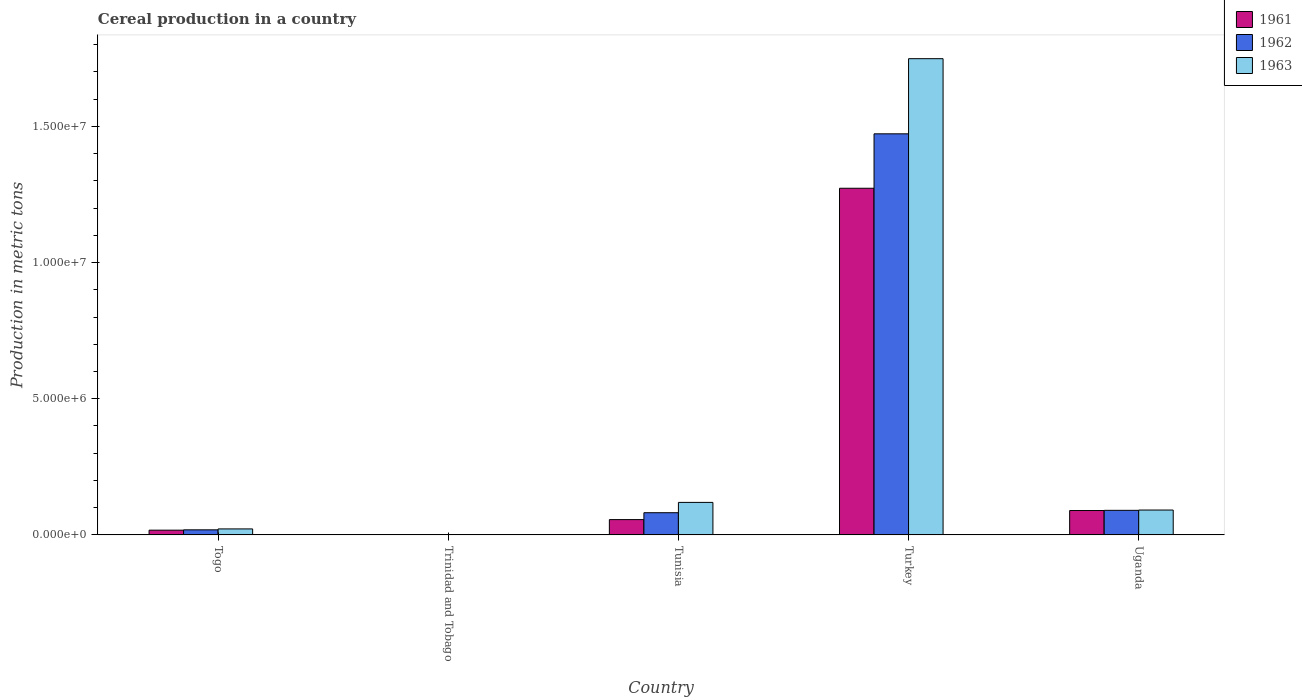How many groups of bars are there?
Keep it short and to the point. 5. Are the number of bars per tick equal to the number of legend labels?
Your response must be concise. Yes. How many bars are there on the 5th tick from the left?
Keep it short and to the point. 3. What is the label of the 5th group of bars from the left?
Provide a short and direct response. Uganda. What is the total cereal production in 1961 in Tunisia?
Make the answer very short. 5.62e+05. Across all countries, what is the maximum total cereal production in 1962?
Your answer should be compact. 1.47e+07. Across all countries, what is the minimum total cereal production in 1963?
Keep it short and to the point. 1.32e+04. In which country was the total cereal production in 1961 maximum?
Make the answer very short. Turkey. In which country was the total cereal production in 1962 minimum?
Your answer should be compact. Trinidad and Tobago. What is the total total cereal production in 1961 in the graph?
Offer a terse response. 1.44e+07. What is the difference between the total cereal production in 1961 in Togo and that in Trinidad and Tobago?
Your answer should be very brief. 1.61e+05. What is the difference between the total cereal production in 1962 in Togo and the total cereal production in 1961 in Trinidad and Tobago?
Provide a short and direct response. 1.73e+05. What is the average total cereal production in 1963 per country?
Provide a succinct answer. 3.97e+06. What is the difference between the total cereal production of/in 1962 and total cereal production of/in 1963 in Trinidad and Tobago?
Keep it short and to the point. 100. What is the ratio of the total cereal production in 1961 in Togo to that in Uganda?
Give a very brief answer. 0.19. Is the total cereal production in 1961 in Trinidad and Tobago less than that in Uganda?
Your answer should be compact. Yes. Is the difference between the total cereal production in 1962 in Togo and Uganda greater than the difference between the total cereal production in 1963 in Togo and Uganda?
Give a very brief answer. No. What is the difference between the highest and the second highest total cereal production in 1963?
Provide a short and direct response. -1.66e+07. What is the difference between the highest and the lowest total cereal production in 1962?
Your answer should be very brief. 1.47e+07. Is the sum of the total cereal production in 1961 in Togo and Tunisia greater than the maximum total cereal production in 1962 across all countries?
Provide a short and direct response. No. What does the 3rd bar from the right in Trinidad and Tobago represents?
Offer a terse response. 1961. How many bars are there?
Your answer should be very brief. 15. What is the difference between two consecutive major ticks on the Y-axis?
Offer a very short reply. 5.00e+06. Does the graph contain any zero values?
Offer a terse response. No. Where does the legend appear in the graph?
Give a very brief answer. Top right. What is the title of the graph?
Give a very brief answer. Cereal production in a country. Does "2004" appear as one of the legend labels in the graph?
Keep it short and to the point. No. What is the label or title of the Y-axis?
Your answer should be very brief. Production in metric tons. What is the Production in metric tons of 1961 in Togo?
Offer a terse response. 1.74e+05. What is the Production in metric tons in 1962 in Togo?
Your response must be concise. 1.86e+05. What is the Production in metric tons of 1963 in Togo?
Offer a very short reply. 2.20e+05. What is the Production in metric tons of 1961 in Trinidad and Tobago?
Your answer should be compact. 1.26e+04. What is the Production in metric tons of 1962 in Trinidad and Tobago?
Ensure brevity in your answer.  1.33e+04. What is the Production in metric tons in 1963 in Trinidad and Tobago?
Offer a terse response. 1.32e+04. What is the Production in metric tons of 1961 in Tunisia?
Provide a succinct answer. 5.62e+05. What is the Production in metric tons of 1962 in Tunisia?
Offer a terse response. 8.14e+05. What is the Production in metric tons of 1963 in Tunisia?
Make the answer very short. 1.19e+06. What is the Production in metric tons in 1961 in Turkey?
Provide a short and direct response. 1.27e+07. What is the Production in metric tons of 1962 in Turkey?
Your answer should be compact. 1.47e+07. What is the Production in metric tons of 1963 in Turkey?
Your answer should be compact. 1.75e+07. What is the Production in metric tons in 1961 in Uganda?
Provide a short and direct response. 8.95e+05. What is the Production in metric tons of 1962 in Uganda?
Make the answer very short. 9.02e+05. What is the Production in metric tons in 1963 in Uganda?
Ensure brevity in your answer.  9.13e+05. Across all countries, what is the maximum Production in metric tons of 1961?
Your answer should be compact. 1.27e+07. Across all countries, what is the maximum Production in metric tons in 1962?
Give a very brief answer. 1.47e+07. Across all countries, what is the maximum Production in metric tons of 1963?
Offer a very short reply. 1.75e+07. Across all countries, what is the minimum Production in metric tons in 1961?
Provide a succinct answer. 1.26e+04. Across all countries, what is the minimum Production in metric tons in 1962?
Your response must be concise. 1.33e+04. Across all countries, what is the minimum Production in metric tons in 1963?
Offer a terse response. 1.32e+04. What is the total Production in metric tons of 1961 in the graph?
Keep it short and to the point. 1.44e+07. What is the total Production in metric tons of 1962 in the graph?
Ensure brevity in your answer.  1.66e+07. What is the total Production in metric tons in 1963 in the graph?
Ensure brevity in your answer.  1.98e+07. What is the difference between the Production in metric tons of 1961 in Togo and that in Trinidad and Tobago?
Provide a succinct answer. 1.61e+05. What is the difference between the Production in metric tons in 1962 in Togo and that in Trinidad and Tobago?
Offer a terse response. 1.72e+05. What is the difference between the Production in metric tons in 1963 in Togo and that in Trinidad and Tobago?
Ensure brevity in your answer.  2.06e+05. What is the difference between the Production in metric tons in 1961 in Togo and that in Tunisia?
Offer a terse response. -3.88e+05. What is the difference between the Production in metric tons of 1962 in Togo and that in Tunisia?
Your answer should be very brief. -6.29e+05. What is the difference between the Production in metric tons of 1963 in Togo and that in Tunisia?
Provide a short and direct response. -9.74e+05. What is the difference between the Production in metric tons of 1961 in Togo and that in Turkey?
Provide a succinct answer. -1.26e+07. What is the difference between the Production in metric tons in 1962 in Togo and that in Turkey?
Your answer should be compact. -1.45e+07. What is the difference between the Production in metric tons of 1963 in Togo and that in Turkey?
Provide a succinct answer. -1.73e+07. What is the difference between the Production in metric tons of 1961 in Togo and that in Uganda?
Make the answer very short. -7.21e+05. What is the difference between the Production in metric tons in 1962 in Togo and that in Uganda?
Provide a succinct answer. -7.16e+05. What is the difference between the Production in metric tons of 1963 in Togo and that in Uganda?
Provide a succinct answer. -6.93e+05. What is the difference between the Production in metric tons in 1961 in Trinidad and Tobago and that in Tunisia?
Give a very brief answer. -5.49e+05. What is the difference between the Production in metric tons in 1962 in Trinidad and Tobago and that in Tunisia?
Provide a succinct answer. -8.01e+05. What is the difference between the Production in metric tons of 1963 in Trinidad and Tobago and that in Tunisia?
Offer a terse response. -1.18e+06. What is the difference between the Production in metric tons of 1961 in Trinidad and Tobago and that in Turkey?
Your response must be concise. -1.27e+07. What is the difference between the Production in metric tons of 1962 in Trinidad and Tobago and that in Turkey?
Your answer should be very brief. -1.47e+07. What is the difference between the Production in metric tons in 1963 in Trinidad and Tobago and that in Turkey?
Provide a short and direct response. -1.75e+07. What is the difference between the Production in metric tons in 1961 in Trinidad and Tobago and that in Uganda?
Provide a succinct answer. -8.83e+05. What is the difference between the Production in metric tons of 1962 in Trinidad and Tobago and that in Uganda?
Your response must be concise. -8.89e+05. What is the difference between the Production in metric tons in 1963 in Trinidad and Tobago and that in Uganda?
Your answer should be very brief. -8.99e+05. What is the difference between the Production in metric tons in 1961 in Tunisia and that in Turkey?
Your response must be concise. -1.22e+07. What is the difference between the Production in metric tons in 1962 in Tunisia and that in Turkey?
Provide a short and direct response. -1.39e+07. What is the difference between the Production in metric tons of 1963 in Tunisia and that in Turkey?
Your answer should be compact. -1.63e+07. What is the difference between the Production in metric tons in 1961 in Tunisia and that in Uganda?
Give a very brief answer. -3.34e+05. What is the difference between the Production in metric tons of 1962 in Tunisia and that in Uganda?
Provide a short and direct response. -8.76e+04. What is the difference between the Production in metric tons in 1963 in Tunisia and that in Uganda?
Give a very brief answer. 2.81e+05. What is the difference between the Production in metric tons in 1961 in Turkey and that in Uganda?
Ensure brevity in your answer.  1.18e+07. What is the difference between the Production in metric tons of 1962 in Turkey and that in Uganda?
Give a very brief answer. 1.38e+07. What is the difference between the Production in metric tons in 1963 in Turkey and that in Uganda?
Your answer should be compact. 1.66e+07. What is the difference between the Production in metric tons in 1961 in Togo and the Production in metric tons in 1962 in Trinidad and Tobago?
Offer a very short reply. 1.61e+05. What is the difference between the Production in metric tons in 1961 in Togo and the Production in metric tons in 1963 in Trinidad and Tobago?
Offer a very short reply. 1.61e+05. What is the difference between the Production in metric tons in 1962 in Togo and the Production in metric tons in 1963 in Trinidad and Tobago?
Offer a very short reply. 1.72e+05. What is the difference between the Production in metric tons of 1961 in Togo and the Production in metric tons of 1962 in Tunisia?
Offer a very short reply. -6.40e+05. What is the difference between the Production in metric tons of 1961 in Togo and the Production in metric tons of 1963 in Tunisia?
Give a very brief answer. -1.02e+06. What is the difference between the Production in metric tons in 1962 in Togo and the Production in metric tons in 1963 in Tunisia?
Offer a very short reply. -1.01e+06. What is the difference between the Production in metric tons of 1961 in Togo and the Production in metric tons of 1962 in Turkey?
Your answer should be compact. -1.46e+07. What is the difference between the Production in metric tons in 1961 in Togo and the Production in metric tons in 1963 in Turkey?
Make the answer very short. -1.73e+07. What is the difference between the Production in metric tons in 1962 in Togo and the Production in metric tons in 1963 in Turkey?
Keep it short and to the point. -1.73e+07. What is the difference between the Production in metric tons of 1961 in Togo and the Production in metric tons of 1962 in Uganda?
Provide a succinct answer. -7.28e+05. What is the difference between the Production in metric tons of 1961 in Togo and the Production in metric tons of 1963 in Uganda?
Give a very brief answer. -7.39e+05. What is the difference between the Production in metric tons in 1962 in Togo and the Production in metric tons in 1963 in Uganda?
Keep it short and to the point. -7.27e+05. What is the difference between the Production in metric tons in 1961 in Trinidad and Tobago and the Production in metric tons in 1962 in Tunisia?
Offer a very short reply. -8.02e+05. What is the difference between the Production in metric tons of 1961 in Trinidad and Tobago and the Production in metric tons of 1963 in Tunisia?
Give a very brief answer. -1.18e+06. What is the difference between the Production in metric tons of 1962 in Trinidad and Tobago and the Production in metric tons of 1963 in Tunisia?
Give a very brief answer. -1.18e+06. What is the difference between the Production in metric tons of 1961 in Trinidad and Tobago and the Production in metric tons of 1962 in Turkey?
Your answer should be very brief. -1.47e+07. What is the difference between the Production in metric tons in 1961 in Trinidad and Tobago and the Production in metric tons in 1963 in Turkey?
Provide a short and direct response. -1.75e+07. What is the difference between the Production in metric tons in 1962 in Trinidad and Tobago and the Production in metric tons in 1963 in Turkey?
Give a very brief answer. -1.75e+07. What is the difference between the Production in metric tons of 1961 in Trinidad and Tobago and the Production in metric tons of 1962 in Uganda?
Provide a short and direct response. -8.89e+05. What is the difference between the Production in metric tons in 1961 in Trinidad and Tobago and the Production in metric tons in 1963 in Uganda?
Provide a succinct answer. -9.00e+05. What is the difference between the Production in metric tons in 1962 in Trinidad and Tobago and the Production in metric tons in 1963 in Uganda?
Offer a very short reply. -8.99e+05. What is the difference between the Production in metric tons of 1961 in Tunisia and the Production in metric tons of 1962 in Turkey?
Provide a succinct answer. -1.42e+07. What is the difference between the Production in metric tons of 1961 in Tunisia and the Production in metric tons of 1963 in Turkey?
Provide a succinct answer. -1.69e+07. What is the difference between the Production in metric tons of 1962 in Tunisia and the Production in metric tons of 1963 in Turkey?
Make the answer very short. -1.67e+07. What is the difference between the Production in metric tons of 1961 in Tunisia and the Production in metric tons of 1962 in Uganda?
Provide a short and direct response. -3.40e+05. What is the difference between the Production in metric tons of 1961 in Tunisia and the Production in metric tons of 1963 in Uganda?
Your answer should be compact. -3.51e+05. What is the difference between the Production in metric tons of 1962 in Tunisia and the Production in metric tons of 1963 in Uganda?
Provide a succinct answer. -9.83e+04. What is the difference between the Production in metric tons of 1961 in Turkey and the Production in metric tons of 1962 in Uganda?
Ensure brevity in your answer.  1.18e+07. What is the difference between the Production in metric tons in 1961 in Turkey and the Production in metric tons in 1963 in Uganda?
Provide a short and direct response. 1.18e+07. What is the difference between the Production in metric tons in 1962 in Turkey and the Production in metric tons in 1963 in Uganda?
Provide a short and direct response. 1.38e+07. What is the average Production in metric tons in 1961 per country?
Keep it short and to the point. 2.87e+06. What is the average Production in metric tons of 1962 per country?
Your response must be concise. 3.33e+06. What is the average Production in metric tons of 1963 per country?
Give a very brief answer. 3.97e+06. What is the difference between the Production in metric tons of 1961 and Production in metric tons of 1962 in Togo?
Offer a terse response. -1.16e+04. What is the difference between the Production in metric tons of 1961 and Production in metric tons of 1963 in Togo?
Provide a succinct answer. -4.57e+04. What is the difference between the Production in metric tons of 1962 and Production in metric tons of 1963 in Togo?
Provide a succinct answer. -3.41e+04. What is the difference between the Production in metric tons in 1961 and Production in metric tons in 1962 in Trinidad and Tobago?
Your response must be concise. -740. What is the difference between the Production in metric tons in 1961 and Production in metric tons in 1963 in Trinidad and Tobago?
Keep it short and to the point. -640. What is the difference between the Production in metric tons in 1961 and Production in metric tons in 1962 in Tunisia?
Provide a short and direct response. -2.53e+05. What is the difference between the Production in metric tons in 1961 and Production in metric tons in 1963 in Tunisia?
Offer a very short reply. -6.32e+05. What is the difference between the Production in metric tons of 1962 and Production in metric tons of 1963 in Tunisia?
Provide a succinct answer. -3.79e+05. What is the difference between the Production in metric tons of 1961 and Production in metric tons of 1962 in Turkey?
Keep it short and to the point. -2.00e+06. What is the difference between the Production in metric tons in 1961 and Production in metric tons in 1963 in Turkey?
Make the answer very short. -4.76e+06. What is the difference between the Production in metric tons of 1962 and Production in metric tons of 1963 in Turkey?
Offer a very short reply. -2.76e+06. What is the difference between the Production in metric tons of 1961 and Production in metric tons of 1962 in Uganda?
Provide a succinct answer. -6800. What is the difference between the Production in metric tons in 1961 and Production in metric tons in 1963 in Uganda?
Provide a short and direct response. -1.74e+04. What is the difference between the Production in metric tons in 1962 and Production in metric tons in 1963 in Uganda?
Ensure brevity in your answer.  -1.06e+04. What is the ratio of the Production in metric tons in 1961 in Togo to that in Trinidad and Tobago?
Give a very brief answer. 13.85. What is the ratio of the Production in metric tons in 1962 in Togo to that in Trinidad and Tobago?
Your answer should be compact. 13.95. What is the ratio of the Production in metric tons in 1963 in Togo to that in Trinidad and Tobago?
Make the answer very short. 16.64. What is the ratio of the Production in metric tons in 1961 in Togo to that in Tunisia?
Provide a short and direct response. 0.31. What is the ratio of the Production in metric tons of 1962 in Togo to that in Tunisia?
Provide a succinct answer. 0.23. What is the ratio of the Production in metric tons of 1963 in Togo to that in Tunisia?
Make the answer very short. 0.18. What is the ratio of the Production in metric tons of 1961 in Togo to that in Turkey?
Ensure brevity in your answer.  0.01. What is the ratio of the Production in metric tons in 1962 in Togo to that in Turkey?
Provide a succinct answer. 0.01. What is the ratio of the Production in metric tons in 1963 in Togo to that in Turkey?
Make the answer very short. 0.01. What is the ratio of the Production in metric tons in 1961 in Togo to that in Uganda?
Provide a succinct answer. 0.19. What is the ratio of the Production in metric tons of 1962 in Togo to that in Uganda?
Keep it short and to the point. 0.21. What is the ratio of the Production in metric tons in 1963 in Togo to that in Uganda?
Your answer should be very brief. 0.24. What is the ratio of the Production in metric tons in 1961 in Trinidad and Tobago to that in Tunisia?
Give a very brief answer. 0.02. What is the ratio of the Production in metric tons in 1962 in Trinidad and Tobago to that in Tunisia?
Offer a very short reply. 0.02. What is the ratio of the Production in metric tons of 1963 in Trinidad and Tobago to that in Tunisia?
Make the answer very short. 0.01. What is the ratio of the Production in metric tons of 1961 in Trinidad and Tobago to that in Turkey?
Give a very brief answer. 0. What is the ratio of the Production in metric tons of 1962 in Trinidad and Tobago to that in Turkey?
Keep it short and to the point. 0. What is the ratio of the Production in metric tons in 1963 in Trinidad and Tobago to that in Turkey?
Provide a succinct answer. 0. What is the ratio of the Production in metric tons of 1961 in Trinidad and Tobago to that in Uganda?
Keep it short and to the point. 0.01. What is the ratio of the Production in metric tons in 1962 in Trinidad and Tobago to that in Uganda?
Ensure brevity in your answer.  0.01. What is the ratio of the Production in metric tons of 1963 in Trinidad and Tobago to that in Uganda?
Your answer should be compact. 0.01. What is the ratio of the Production in metric tons of 1961 in Tunisia to that in Turkey?
Offer a terse response. 0.04. What is the ratio of the Production in metric tons in 1962 in Tunisia to that in Turkey?
Ensure brevity in your answer.  0.06. What is the ratio of the Production in metric tons of 1963 in Tunisia to that in Turkey?
Give a very brief answer. 0.07. What is the ratio of the Production in metric tons in 1961 in Tunisia to that in Uganda?
Your answer should be very brief. 0.63. What is the ratio of the Production in metric tons in 1962 in Tunisia to that in Uganda?
Your answer should be very brief. 0.9. What is the ratio of the Production in metric tons of 1963 in Tunisia to that in Uganda?
Your answer should be very brief. 1.31. What is the ratio of the Production in metric tons of 1961 in Turkey to that in Uganda?
Your response must be concise. 14.22. What is the ratio of the Production in metric tons in 1962 in Turkey to that in Uganda?
Ensure brevity in your answer.  16.33. What is the ratio of the Production in metric tons of 1963 in Turkey to that in Uganda?
Offer a terse response. 19.16. What is the difference between the highest and the second highest Production in metric tons in 1961?
Provide a short and direct response. 1.18e+07. What is the difference between the highest and the second highest Production in metric tons of 1962?
Your response must be concise. 1.38e+07. What is the difference between the highest and the second highest Production in metric tons in 1963?
Your response must be concise. 1.63e+07. What is the difference between the highest and the lowest Production in metric tons in 1961?
Make the answer very short. 1.27e+07. What is the difference between the highest and the lowest Production in metric tons in 1962?
Provide a short and direct response. 1.47e+07. What is the difference between the highest and the lowest Production in metric tons in 1963?
Offer a very short reply. 1.75e+07. 